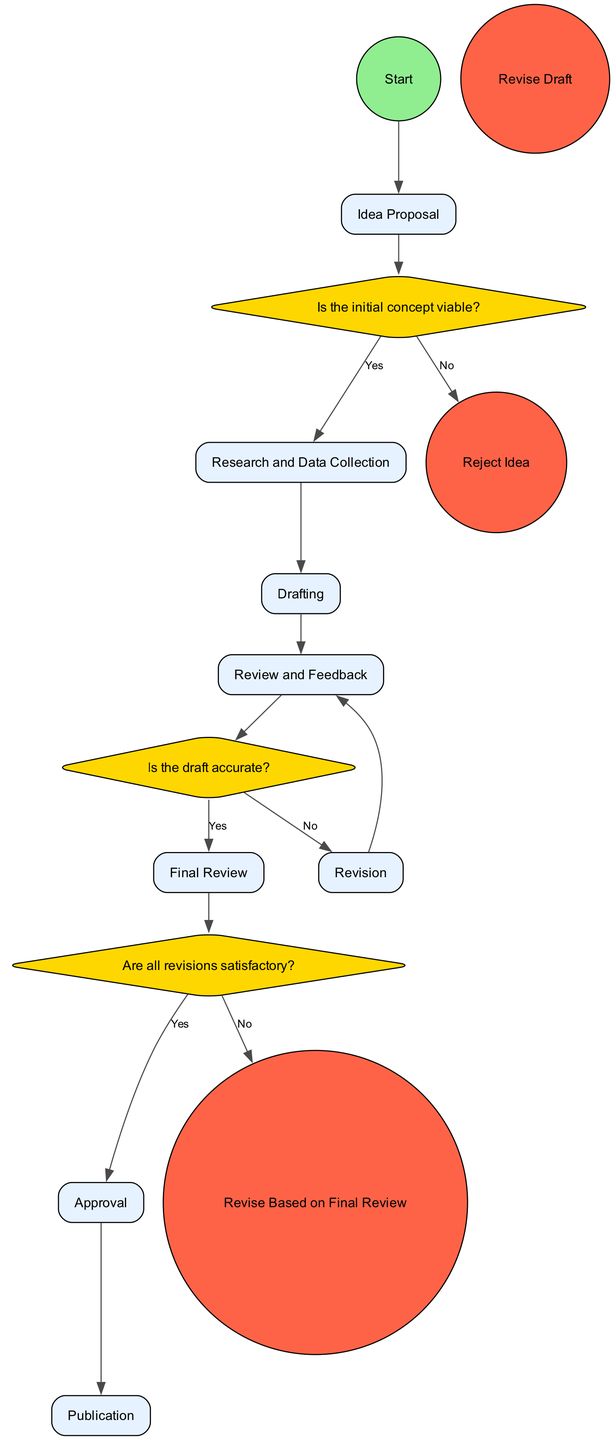What is the first activity in the workflow? The diagram starts with the 'Idea Proposal' activity, which is the first node directly connected to the start node.
Answer: Idea Proposal How many decision points are present in the diagram? There are three decision points labeled as D1, D2, and D3; thus, the count is verified by counting them visually in the diagram.
Answer: 3 What happens if the initial concept is not viable? Following the 'Is the initial concept viable?' decision, if the answer is 'No', the flow directs to the 'Reject Idea' end event, indicating that the concept is discarded.
Answer: Reject Idea What is the purpose of the 'Final Review' activity? The 'Final Review' activity is conducted by the mental health professional to ensure that all revisions made by the writer are accurate before final approval.
Answer: Ensures accuracy How does the workflow continue after the draft is found inaccurate? If the draft is found to be inaccurate (based on decision D2), the workflow directs back to the 'Revision' activity, allowing the writer to revise the content accordingly.
Answer: Revise Draft What is the last activity in the workflow? The final activity represented in the diagram is 'Publication,' which signifies that the approved content has been published to the intended audience.
Answer: Publication What action takes place after the writing draft is created? After the draft is created, it is sent for 'Review and Feedback' by the mental health professional to assess its accuracy and provide suggestions for improvement.
Answer: Review and Feedback Which two roles are involved in this collaboration workflow? The two roles identified in the diagram are 'Writer,' who creates content, and 'Mental Health Professional,' who provides expertise and reviews the content.
Answer: Writer; Mental Health Professional 